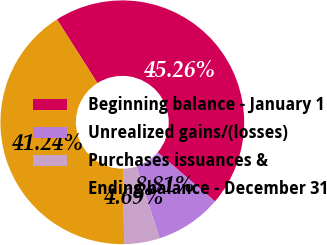Convert chart to OTSL. <chart><loc_0><loc_0><loc_500><loc_500><pie_chart><fcel>Beginning balance - January 1<fcel>Unrealized gains/(losses)<fcel>Purchases issuances &<fcel>Ending balance - December 31<nl><fcel>45.26%<fcel>8.81%<fcel>4.69%<fcel>41.24%<nl></chart> 